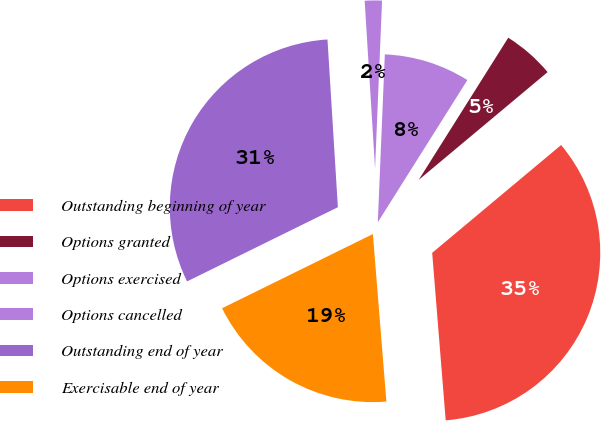Convert chart. <chart><loc_0><loc_0><loc_500><loc_500><pie_chart><fcel>Outstanding beginning of year<fcel>Options granted<fcel>Options exercised<fcel>Options cancelled<fcel>Outstanding end of year<fcel>Exercisable end of year<nl><fcel>34.8%<fcel>4.97%<fcel>8.28%<fcel>1.65%<fcel>31.29%<fcel>19.0%<nl></chart> 